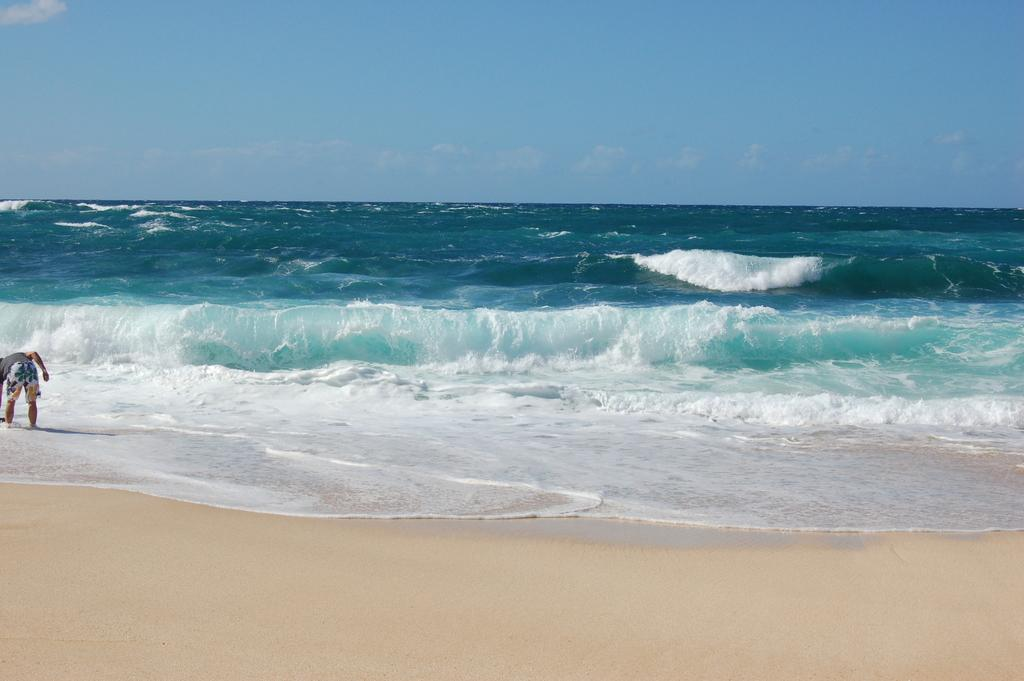What is the person in the image doing? The person is standing in the water. What can be seen at the bottom of the image? There is sand at the bottom of the image. What is visible at the top of the image? The sky is visible at the top of the image. How many ducks are swimming in the water with the person? There are no ducks present in the image; it only shows a person standing in the water. 